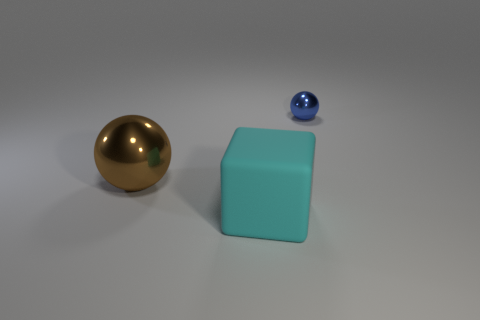What number of brown balls are there?
Your answer should be compact. 1. How many brown shiny things have the same shape as the cyan rubber thing?
Your response must be concise. 0. Does the tiny blue metal object have the same shape as the brown object?
Your response must be concise. Yes. What size is the matte object?
Provide a short and direct response. Large. What number of green metal things have the same size as the matte thing?
Provide a succinct answer. 0. There is a sphere that is left of the small blue thing; is it the same size as the sphere that is to the right of the big cube?
Keep it short and to the point. No. What shape is the metallic thing that is to the right of the cyan thing?
Provide a short and direct response. Sphere. What is the material of the ball that is to the right of the metal sphere that is on the left side of the blue shiny thing?
Ensure brevity in your answer.  Metal. Are there any metallic things of the same color as the big metallic sphere?
Your response must be concise. No. Is the size of the rubber object the same as the metallic sphere that is in front of the small metal object?
Your response must be concise. Yes. 